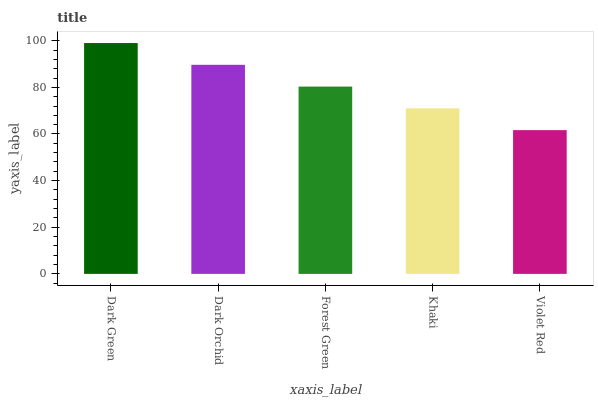Is Violet Red the minimum?
Answer yes or no. Yes. Is Dark Green the maximum?
Answer yes or no. Yes. Is Dark Orchid the minimum?
Answer yes or no. No. Is Dark Orchid the maximum?
Answer yes or no. No. Is Dark Green greater than Dark Orchid?
Answer yes or no. Yes. Is Dark Orchid less than Dark Green?
Answer yes or no. Yes. Is Dark Orchid greater than Dark Green?
Answer yes or no. No. Is Dark Green less than Dark Orchid?
Answer yes or no. No. Is Forest Green the high median?
Answer yes or no. Yes. Is Forest Green the low median?
Answer yes or no. Yes. Is Violet Red the high median?
Answer yes or no. No. Is Dark Orchid the low median?
Answer yes or no. No. 